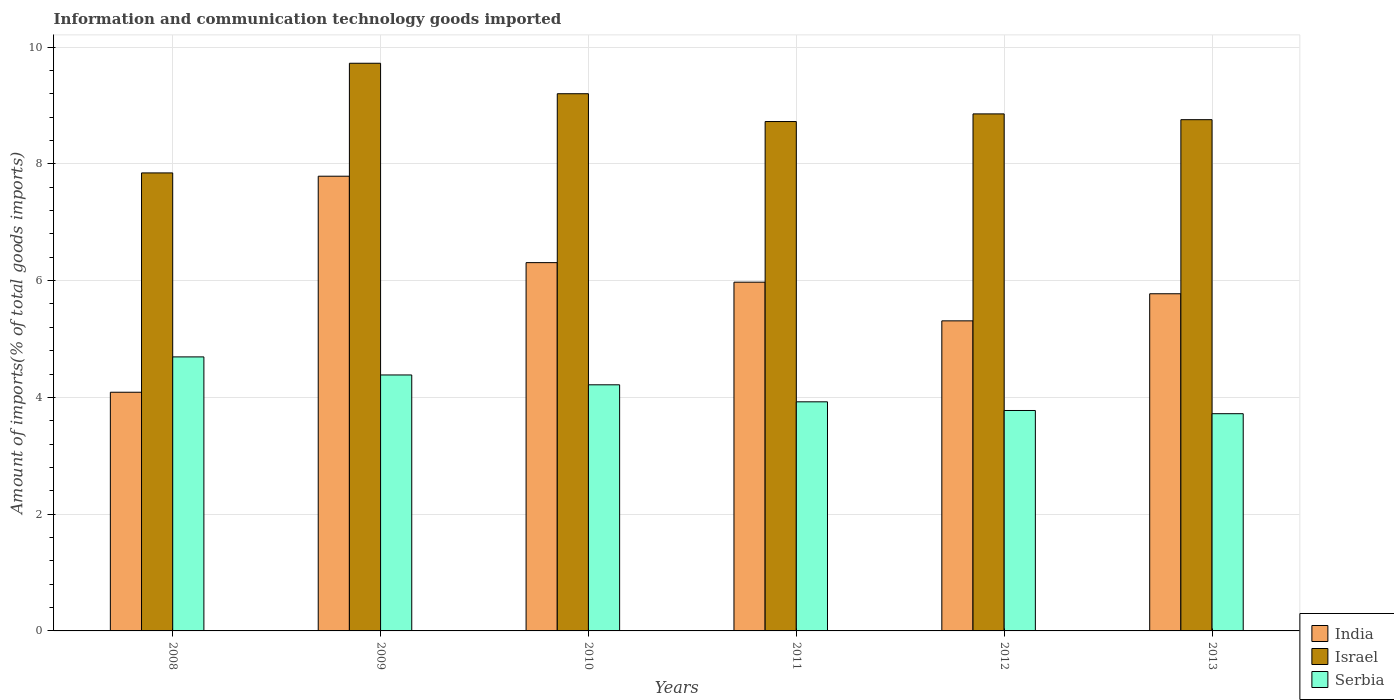How many different coloured bars are there?
Offer a very short reply. 3. How many bars are there on the 5th tick from the right?
Offer a very short reply. 3. What is the amount of goods imported in India in 2012?
Your answer should be compact. 5.31. Across all years, what is the maximum amount of goods imported in Israel?
Ensure brevity in your answer.  9.72. Across all years, what is the minimum amount of goods imported in Serbia?
Keep it short and to the point. 3.72. In which year was the amount of goods imported in Israel maximum?
Ensure brevity in your answer.  2009. In which year was the amount of goods imported in India minimum?
Provide a short and direct response. 2008. What is the total amount of goods imported in India in the graph?
Ensure brevity in your answer.  35.25. What is the difference between the amount of goods imported in India in 2009 and that in 2012?
Provide a short and direct response. 2.48. What is the difference between the amount of goods imported in Serbia in 2011 and the amount of goods imported in India in 2010?
Give a very brief answer. -2.38. What is the average amount of goods imported in Serbia per year?
Provide a short and direct response. 4.12. In the year 2010, what is the difference between the amount of goods imported in Israel and amount of goods imported in Serbia?
Make the answer very short. 4.99. What is the ratio of the amount of goods imported in Serbia in 2011 to that in 2013?
Your answer should be very brief. 1.05. What is the difference between the highest and the second highest amount of goods imported in India?
Your answer should be compact. 1.48. What is the difference between the highest and the lowest amount of goods imported in Israel?
Offer a very short reply. 1.88. In how many years, is the amount of goods imported in India greater than the average amount of goods imported in India taken over all years?
Ensure brevity in your answer.  3. Is the sum of the amount of goods imported in Serbia in 2008 and 2012 greater than the maximum amount of goods imported in Israel across all years?
Keep it short and to the point. No. What does the 3rd bar from the left in 2012 represents?
Offer a terse response. Serbia. What does the 2nd bar from the right in 2012 represents?
Keep it short and to the point. Israel. Is it the case that in every year, the sum of the amount of goods imported in Israel and amount of goods imported in India is greater than the amount of goods imported in Serbia?
Keep it short and to the point. Yes. Are all the bars in the graph horizontal?
Your answer should be compact. No. Does the graph contain any zero values?
Offer a very short reply. No. Does the graph contain grids?
Offer a terse response. Yes. How many legend labels are there?
Your answer should be very brief. 3. What is the title of the graph?
Make the answer very short. Information and communication technology goods imported. Does "Benin" appear as one of the legend labels in the graph?
Your response must be concise. No. What is the label or title of the Y-axis?
Ensure brevity in your answer.  Amount of imports(% of total goods imports). What is the Amount of imports(% of total goods imports) of India in 2008?
Make the answer very short. 4.09. What is the Amount of imports(% of total goods imports) of Israel in 2008?
Your answer should be very brief. 7.85. What is the Amount of imports(% of total goods imports) in Serbia in 2008?
Make the answer very short. 4.69. What is the Amount of imports(% of total goods imports) of India in 2009?
Make the answer very short. 7.79. What is the Amount of imports(% of total goods imports) of Israel in 2009?
Offer a terse response. 9.72. What is the Amount of imports(% of total goods imports) of Serbia in 2009?
Your response must be concise. 4.38. What is the Amount of imports(% of total goods imports) of India in 2010?
Make the answer very short. 6.31. What is the Amount of imports(% of total goods imports) in Israel in 2010?
Offer a terse response. 9.2. What is the Amount of imports(% of total goods imports) of Serbia in 2010?
Offer a very short reply. 4.22. What is the Amount of imports(% of total goods imports) of India in 2011?
Keep it short and to the point. 5.97. What is the Amount of imports(% of total goods imports) of Israel in 2011?
Offer a terse response. 8.73. What is the Amount of imports(% of total goods imports) in Serbia in 2011?
Offer a terse response. 3.92. What is the Amount of imports(% of total goods imports) of India in 2012?
Provide a succinct answer. 5.31. What is the Amount of imports(% of total goods imports) of Israel in 2012?
Provide a short and direct response. 8.86. What is the Amount of imports(% of total goods imports) of Serbia in 2012?
Ensure brevity in your answer.  3.78. What is the Amount of imports(% of total goods imports) in India in 2013?
Your response must be concise. 5.78. What is the Amount of imports(% of total goods imports) in Israel in 2013?
Your response must be concise. 8.76. What is the Amount of imports(% of total goods imports) in Serbia in 2013?
Give a very brief answer. 3.72. Across all years, what is the maximum Amount of imports(% of total goods imports) of India?
Your response must be concise. 7.79. Across all years, what is the maximum Amount of imports(% of total goods imports) of Israel?
Provide a succinct answer. 9.72. Across all years, what is the maximum Amount of imports(% of total goods imports) in Serbia?
Your response must be concise. 4.69. Across all years, what is the minimum Amount of imports(% of total goods imports) in India?
Offer a very short reply. 4.09. Across all years, what is the minimum Amount of imports(% of total goods imports) of Israel?
Your answer should be compact. 7.85. Across all years, what is the minimum Amount of imports(% of total goods imports) in Serbia?
Ensure brevity in your answer.  3.72. What is the total Amount of imports(% of total goods imports) of India in the graph?
Keep it short and to the point. 35.25. What is the total Amount of imports(% of total goods imports) in Israel in the graph?
Offer a terse response. 53.11. What is the total Amount of imports(% of total goods imports) in Serbia in the graph?
Provide a succinct answer. 24.71. What is the difference between the Amount of imports(% of total goods imports) in India in 2008 and that in 2009?
Your response must be concise. -3.7. What is the difference between the Amount of imports(% of total goods imports) of Israel in 2008 and that in 2009?
Your answer should be very brief. -1.88. What is the difference between the Amount of imports(% of total goods imports) in Serbia in 2008 and that in 2009?
Your answer should be compact. 0.31. What is the difference between the Amount of imports(% of total goods imports) of India in 2008 and that in 2010?
Offer a very short reply. -2.22. What is the difference between the Amount of imports(% of total goods imports) of Israel in 2008 and that in 2010?
Offer a very short reply. -1.36. What is the difference between the Amount of imports(% of total goods imports) of Serbia in 2008 and that in 2010?
Your answer should be compact. 0.48. What is the difference between the Amount of imports(% of total goods imports) in India in 2008 and that in 2011?
Ensure brevity in your answer.  -1.89. What is the difference between the Amount of imports(% of total goods imports) of Israel in 2008 and that in 2011?
Keep it short and to the point. -0.88. What is the difference between the Amount of imports(% of total goods imports) of Serbia in 2008 and that in 2011?
Your answer should be very brief. 0.77. What is the difference between the Amount of imports(% of total goods imports) of India in 2008 and that in 2012?
Offer a terse response. -1.22. What is the difference between the Amount of imports(% of total goods imports) in Israel in 2008 and that in 2012?
Your answer should be very brief. -1.01. What is the difference between the Amount of imports(% of total goods imports) in Serbia in 2008 and that in 2012?
Provide a short and direct response. 0.92. What is the difference between the Amount of imports(% of total goods imports) of India in 2008 and that in 2013?
Provide a succinct answer. -1.69. What is the difference between the Amount of imports(% of total goods imports) in Israel in 2008 and that in 2013?
Give a very brief answer. -0.91. What is the difference between the Amount of imports(% of total goods imports) of India in 2009 and that in 2010?
Give a very brief answer. 1.48. What is the difference between the Amount of imports(% of total goods imports) of Israel in 2009 and that in 2010?
Your response must be concise. 0.52. What is the difference between the Amount of imports(% of total goods imports) of Serbia in 2009 and that in 2010?
Keep it short and to the point. 0.17. What is the difference between the Amount of imports(% of total goods imports) in India in 2009 and that in 2011?
Offer a very short reply. 1.81. What is the difference between the Amount of imports(% of total goods imports) of Israel in 2009 and that in 2011?
Ensure brevity in your answer.  1. What is the difference between the Amount of imports(% of total goods imports) of Serbia in 2009 and that in 2011?
Give a very brief answer. 0.46. What is the difference between the Amount of imports(% of total goods imports) in India in 2009 and that in 2012?
Ensure brevity in your answer.  2.48. What is the difference between the Amount of imports(% of total goods imports) in Israel in 2009 and that in 2012?
Your answer should be very brief. 0.87. What is the difference between the Amount of imports(% of total goods imports) of Serbia in 2009 and that in 2012?
Keep it short and to the point. 0.61. What is the difference between the Amount of imports(% of total goods imports) of India in 2009 and that in 2013?
Keep it short and to the point. 2.01. What is the difference between the Amount of imports(% of total goods imports) in Israel in 2009 and that in 2013?
Provide a succinct answer. 0.97. What is the difference between the Amount of imports(% of total goods imports) of Serbia in 2009 and that in 2013?
Keep it short and to the point. 0.66. What is the difference between the Amount of imports(% of total goods imports) of India in 2010 and that in 2011?
Give a very brief answer. 0.33. What is the difference between the Amount of imports(% of total goods imports) of Israel in 2010 and that in 2011?
Make the answer very short. 0.48. What is the difference between the Amount of imports(% of total goods imports) of Serbia in 2010 and that in 2011?
Your answer should be very brief. 0.29. What is the difference between the Amount of imports(% of total goods imports) of Israel in 2010 and that in 2012?
Give a very brief answer. 0.35. What is the difference between the Amount of imports(% of total goods imports) in Serbia in 2010 and that in 2012?
Make the answer very short. 0.44. What is the difference between the Amount of imports(% of total goods imports) of India in 2010 and that in 2013?
Provide a short and direct response. 0.53. What is the difference between the Amount of imports(% of total goods imports) in Israel in 2010 and that in 2013?
Provide a succinct answer. 0.44. What is the difference between the Amount of imports(% of total goods imports) of Serbia in 2010 and that in 2013?
Offer a terse response. 0.49. What is the difference between the Amount of imports(% of total goods imports) in India in 2011 and that in 2012?
Make the answer very short. 0.66. What is the difference between the Amount of imports(% of total goods imports) in Israel in 2011 and that in 2012?
Provide a short and direct response. -0.13. What is the difference between the Amount of imports(% of total goods imports) in Serbia in 2011 and that in 2012?
Provide a short and direct response. 0.15. What is the difference between the Amount of imports(% of total goods imports) in India in 2011 and that in 2013?
Give a very brief answer. 0.2. What is the difference between the Amount of imports(% of total goods imports) of Israel in 2011 and that in 2013?
Give a very brief answer. -0.03. What is the difference between the Amount of imports(% of total goods imports) in Serbia in 2011 and that in 2013?
Your answer should be very brief. 0.2. What is the difference between the Amount of imports(% of total goods imports) of India in 2012 and that in 2013?
Your response must be concise. -0.46. What is the difference between the Amount of imports(% of total goods imports) in Israel in 2012 and that in 2013?
Your answer should be very brief. 0.1. What is the difference between the Amount of imports(% of total goods imports) of Serbia in 2012 and that in 2013?
Ensure brevity in your answer.  0.06. What is the difference between the Amount of imports(% of total goods imports) in India in 2008 and the Amount of imports(% of total goods imports) in Israel in 2009?
Provide a short and direct response. -5.64. What is the difference between the Amount of imports(% of total goods imports) of India in 2008 and the Amount of imports(% of total goods imports) of Serbia in 2009?
Your answer should be compact. -0.3. What is the difference between the Amount of imports(% of total goods imports) of Israel in 2008 and the Amount of imports(% of total goods imports) of Serbia in 2009?
Provide a succinct answer. 3.46. What is the difference between the Amount of imports(% of total goods imports) in India in 2008 and the Amount of imports(% of total goods imports) in Israel in 2010?
Your answer should be very brief. -5.11. What is the difference between the Amount of imports(% of total goods imports) in India in 2008 and the Amount of imports(% of total goods imports) in Serbia in 2010?
Ensure brevity in your answer.  -0.13. What is the difference between the Amount of imports(% of total goods imports) of Israel in 2008 and the Amount of imports(% of total goods imports) of Serbia in 2010?
Provide a short and direct response. 3.63. What is the difference between the Amount of imports(% of total goods imports) in India in 2008 and the Amount of imports(% of total goods imports) in Israel in 2011?
Make the answer very short. -4.64. What is the difference between the Amount of imports(% of total goods imports) in India in 2008 and the Amount of imports(% of total goods imports) in Serbia in 2011?
Offer a terse response. 0.16. What is the difference between the Amount of imports(% of total goods imports) of Israel in 2008 and the Amount of imports(% of total goods imports) of Serbia in 2011?
Give a very brief answer. 3.92. What is the difference between the Amount of imports(% of total goods imports) of India in 2008 and the Amount of imports(% of total goods imports) of Israel in 2012?
Keep it short and to the point. -4.77. What is the difference between the Amount of imports(% of total goods imports) in India in 2008 and the Amount of imports(% of total goods imports) in Serbia in 2012?
Give a very brief answer. 0.31. What is the difference between the Amount of imports(% of total goods imports) of Israel in 2008 and the Amount of imports(% of total goods imports) of Serbia in 2012?
Ensure brevity in your answer.  4.07. What is the difference between the Amount of imports(% of total goods imports) of India in 2008 and the Amount of imports(% of total goods imports) of Israel in 2013?
Keep it short and to the point. -4.67. What is the difference between the Amount of imports(% of total goods imports) of India in 2008 and the Amount of imports(% of total goods imports) of Serbia in 2013?
Give a very brief answer. 0.37. What is the difference between the Amount of imports(% of total goods imports) in Israel in 2008 and the Amount of imports(% of total goods imports) in Serbia in 2013?
Your answer should be compact. 4.12. What is the difference between the Amount of imports(% of total goods imports) in India in 2009 and the Amount of imports(% of total goods imports) in Israel in 2010?
Ensure brevity in your answer.  -1.41. What is the difference between the Amount of imports(% of total goods imports) in India in 2009 and the Amount of imports(% of total goods imports) in Serbia in 2010?
Keep it short and to the point. 3.57. What is the difference between the Amount of imports(% of total goods imports) in Israel in 2009 and the Amount of imports(% of total goods imports) in Serbia in 2010?
Ensure brevity in your answer.  5.51. What is the difference between the Amount of imports(% of total goods imports) in India in 2009 and the Amount of imports(% of total goods imports) in Israel in 2011?
Offer a terse response. -0.94. What is the difference between the Amount of imports(% of total goods imports) of India in 2009 and the Amount of imports(% of total goods imports) of Serbia in 2011?
Offer a terse response. 3.86. What is the difference between the Amount of imports(% of total goods imports) of Israel in 2009 and the Amount of imports(% of total goods imports) of Serbia in 2011?
Keep it short and to the point. 5.8. What is the difference between the Amount of imports(% of total goods imports) in India in 2009 and the Amount of imports(% of total goods imports) in Israel in 2012?
Ensure brevity in your answer.  -1.07. What is the difference between the Amount of imports(% of total goods imports) of India in 2009 and the Amount of imports(% of total goods imports) of Serbia in 2012?
Provide a short and direct response. 4.01. What is the difference between the Amount of imports(% of total goods imports) of Israel in 2009 and the Amount of imports(% of total goods imports) of Serbia in 2012?
Offer a terse response. 5.95. What is the difference between the Amount of imports(% of total goods imports) in India in 2009 and the Amount of imports(% of total goods imports) in Israel in 2013?
Give a very brief answer. -0.97. What is the difference between the Amount of imports(% of total goods imports) of India in 2009 and the Amount of imports(% of total goods imports) of Serbia in 2013?
Give a very brief answer. 4.07. What is the difference between the Amount of imports(% of total goods imports) of Israel in 2009 and the Amount of imports(% of total goods imports) of Serbia in 2013?
Give a very brief answer. 6. What is the difference between the Amount of imports(% of total goods imports) in India in 2010 and the Amount of imports(% of total goods imports) in Israel in 2011?
Offer a very short reply. -2.42. What is the difference between the Amount of imports(% of total goods imports) of India in 2010 and the Amount of imports(% of total goods imports) of Serbia in 2011?
Your answer should be compact. 2.38. What is the difference between the Amount of imports(% of total goods imports) in Israel in 2010 and the Amount of imports(% of total goods imports) in Serbia in 2011?
Keep it short and to the point. 5.28. What is the difference between the Amount of imports(% of total goods imports) in India in 2010 and the Amount of imports(% of total goods imports) in Israel in 2012?
Offer a terse response. -2.55. What is the difference between the Amount of imports(% of total goods imports) in India in 2010 and the Amount of imports(% of total goods imports) in Serbia in 2012?
Your answer should be very brief. 2.53. What is the difference between the Amount of imports(% of total goods imports) of Israel in 2010 and the Amount of imports(% of total goods imports) of Serbia in 2012?
Make the answer very short. 5.43. What is the difference between the Amount of imports(% of total goods imports) of India in 2010 and the Amount of imports(% of total goods imports) of Israel in 2013?
Ensure brevity in your answer.  -2.45. What is the difference between the Amount of imports(% of total goods imports) of India in 2010 and the Amount of imports(% of total goods imports) of Serbia in 2013?
Offer a very short reply. 2.59. What is the difference between the Amount of imports(% of total goods imports) of Israel in 2010 and the Amount of imports(% of total goods imports) of Serbia in 2013?
Offer a very short reply. 5.48. What is the difference between the Amount of imports(% of total goods imports) of India in 2011 and the Amount of imports(% of total goods imports) of Israel in 2012?
Give a very brief answer. -2.88. What is the difference between the Amount of imports(% of total goods imports) in India in 2011 and the Amount of imports(% of total goods imports) in Serbia in 2012?
Ensure brevity in your answer.  2.2. What is the difference between the Amount of imports(% of total goods imports) in Israel in 2011 and the Amount of imports(% of total goods imports) in Serbia in 2012?
Provide a short and direct response. 4.95. What is the difference between the Amount of imports(% of total goods imports) in India in 2011 and the Amount of imports(% of total goods imports) in Israel in 2013?
Provide a short and direct response. -2.78. What is the difference between the Amount of imports(% of total goods imports) in India in 2011 and the Amount of imports(% of total goods imports) in Serbia in 2013?
Your answer should be compact. 2.25. What is the difference between the Amount of imports(% of total goods imports) in Israel in 2011 and the Amount of imports(% of total goods imports) in Serbia in 2013?
Provide a short and direct response. 5. What is the difference between the Amount of imports(% of total goods imports) in India in 2012 and the Amount of imports(% of total goods imports) in Israel in 2013?
Provide a succinct answer. -3.45. What is the difference between the Amount of imports(% of total goods imports) of India in 2012 and the Amount of imports(% of total goods imports) of Serbia in 2013?
Make the answer very short. 1.59. What is the difference between the Amount of imports(% of total goods imports) of Israel in 2012 and the Amount of imports(% of total goods imports) of Serbia in 2013?
Offer a very short reply. 5.14. What is the average Amount of imports(% of total goods imports) of India per year?
Your answer should be very brief. 5.87. What is the average Amount of imports(% of total goods imports) of Israel per year?
Keep it short and to the point. 8.85. What is the average Amount of imports(% of total goods imports) in Serbia per year?
Provide a short and direct response. 4.12. In the year 2008, what is the difference between the Amount of imports(% of total goods imports) in India and Amount of imports(% of total goods imports) in Israel?
Your answer should be compact. -3.76. In the year 2008, what is the difference between the Amount of imports(% of total goods imports) of India and Amount of imports(% of total goods imports) of Serbia?
Offer a terse response. -0.61. In the year 2008, what is the difference between the Amount of imports(% of total goods imports) in Israel and Amount of imports(% of total goods imports) in Serbia?
Ensure brevity in your answer.  3.15. In the year 2009, what is the difference between the Amount of imports(% of total goods imports) of India and Amount of imports(% of total goods imports) of Israel?
Keep it short and to the point. -1.93. In the year 2009, what is the difference between the Amount of imports(% of total goods imports) of India and Amount of imports(% of total goods imports) of Serbia?
Offer a terse response. 3.4. In the year 2009, what is the difference between the Amount of imports(% of total goods imports) of Israel and Amount of imports(% of total goods imports) of Serbia?
Provide a short and direct response. 5.34. In the year 2010, what is the difference between the Amount of imports(% of total goods imports) in India and Amount of imports(% of total goods imports) in Israel?
Offer a terse response. -2.89. In the year 2010, what is the difference between the Amount of imports(% of total goods imports) in India and Amount of imports(% of total goods imports) in Serbia?
Make the answer very short. 2.09. In the year 2010, what is the difference between the Amount of imports(% of total goods imports) in Israel and Amount of imports(% of total goods imports) in Serbia?
Keep it short and to the point. 4.99. In the year 2011, what is the difference between the Amount of imports(% of total goods imports) in India and Amount of imports(% of total goods imports) in Israel?
Provide a succinct answer. -2.75. In the year 2011, what is the difference between the Amount of imports(% of total goods imports) of India and Amount of imports(% of total goods imports) of Serbia?
Your answer should be compact. 2.05. In the year 2011, what is the difference between the Amount of imports(% of total goods imports) in Israel and Amount of imports(% of total goods imports) in Serbia?
Provide a short and direct response. 4.8. In the year 2012, what is the difference between the Amount of imports(% of total goods imports) in India and Amount of imports(% of total goods imports) in Israel?
Your answer should be very brief. -3.54. In the year 2012, what is the difference between the Amount of imports(% of total goods imports) of India and Amount of imports(% of total goods imports) of Serbia?
Offer a very short reply. 1.54. In the year 2012, what is the difference between the Amount of imports(% of total goods imports) in Israel and Amount of imports(% of total goods imports) in Serbia?
Provide a succinct answer. 5.08. In the year 2013, what is the difference between the Amount of imports(% of total goods imports) in India and Amount of imports(% of total goods imports) in Israel?
Offer a very short reply. -2.98. In the year 2013, what is the difference between the Amount of imports(% of total goods imports) of India and Amount of imports(% of total goods imports) of Serbia?
Provide a succinct answer. 2.05. In the year 2013, what is the difference between the Amount of imports(% of total goods imports) in Israel and Amount of imports(% of total goods imports) in Serbia?
Your answer should be compact. 5.04. What is the ratio of the Amount of imports(% of total goods imports) of India in 2008 to that in 2009?
Keep it short and to the point. 0.52. What is the ratio of the Amount of imports(% of total goods imports) in Israel in 2008 to that in 2009?
Give a very brief answer. 0.81. What is the ratio of the Amount of imports(% of total goods imports) of Serbia in 2008 to that in 2009?
Offer a terse response. 1.07. What is the ratio of the Amount of imports(% of total goods imports) in India in 2008 to that in 2010?
Make the answer very short. 0.65. What is the ratio of the Amount of imports(% of total goods imports) in Israel in 2008 to that in 2010?
Keep it short and to the point. 0.85. What is the ratio of the Amount of imports(% of total goods imports) in Serbia in 2008 to that in 2010?
Keep it short and to the point. 1.11. What is the ratio of the Amount of imports(% of total goods imports) of India in 2008 to that in 2011?
Your response must be concise. 0.68. What is the ratio of the Amount of imports(% of total goods imports) in Israel in 2008 to that in 2011?
Provide a succinct answer. 0.9. What is the ratio of the Amount of imports(% of total goods imports) in Serbia in 2008 to that in 2011?
Your response must be concise. 1.2. What is the ratio of the Amount of imports(% of total goods imports) of India in 2008 to that in 2012?
Your response must be concise. 0.77. What is the ratio of the Amount of imports(% of total goods imports) in Israel in 2008 to that in 2012?
Provide a succinct answer. 0.89. What is the ratio of the Amount of imports(% of total goods imports) in Serbia in 2008 to that in 2012?
Make the answer very short. 1.24. What is the ratio of the Amount of imports(% of total goods imports) in India in 2008 to that in 2013?
Your response must be concise. 0.71. What is the ratio of the Amount of imports(% of total goods imports) of Israel in 2008 to that in 2013?
Your answer should be very brief. 0.9. What is the ratio of the Amount of imports(% of total goods imports) in Serbia in 2008 to that in 2013?
Offer a very short reply. 1.26. What is the ratio of the Amount of imports(% of total goods imports) of India in 2009 to that in 2010?
Offer a very short reply. 1.23. What is the ratio of the Amount of imports(% of total goods imports) of Israel in 2009 to that in 2010?
Give a very brief answer. 1.06. What is the ratio of the Amount of imports(% of total goods imports) in India in 2009 to that in 2011?
Provide a short and direct response. 1.3. What is the ratio of the Amount of imports(% of total goods imports) of Israel in 2009 to that in 2011?
Offer a terse response. 1.11. What is the ratio of the Amount of imports(% of total goods imports) of Serbia in 2009 to that in 2011?
Your answer should be very brief. 1.12. What is the ratio of the Amount of imports(% of total goods imports) of India in 2009 to that in 2012?
Provide a short and direct response. 1.47. What is the ratio of the Amount of imports(% of total goods imports) in Israel in 2009 to that in 2012?
Your answer should be very brief. 1.1. What is the ratio of the Amount of imports(% of total goods imports) in Serbia in 2009 to that in 2012?
Your response must be concise. 1.16. What is the ratio of the Amount of imports(% of total goods imports) of India in 2009 to that in 2013?
Offer a very short reply. 1.35. What is the ratio of the Amount of imports(% of total goods imports) of Israel in 2009 to that in 2013?
Provide a succinct answer. 1.11. What is the ratio of the Amount of imports(% of total goods imports) of Serbia in 2009 to that in 2013?
Provide a short and direct response. 1.18. What is the ratio of the Amount of imports(% of total goods imports) in India in 2010 to that in 2011?
Keep it short and to the point. 1.06. What is the ratio of the Amount of imports(% of total goods imports) of Israel in 2010 to that in 2011?
Your answer should be very brief. 1.05. What is the ratio of the Amount of imports(% of total goods imports) of Serbia in 2010 to that in 2011?
Provide a succinct answer. 1.07. What is the ratio of the Amount of imports(% of total goods imports) of India in 2010 to that in 2012?
Ensure brevity in your answer.  1.19. What is the ratio of the Amount of imports(% of total goods imports) of Israel in 2010 to that in 2012?
Keep it short and to the point. 1.04. What is the ratio of the Amount of imports(% of total goods imports) in Serbia in 2010 to that in 2012?
Your answer should be compact. 1.12. What is the ratio of the Amount of imports(% of total goods imports) in India in 2010 to that in 2013?
Your response must be concise. 1.09. What is the ratio of the Amount of imports(% of total goods imports) in Israel in 2010 to that in 2013?
Provide a succinct answer. 1.05. What is the ratio of the Amount of imports(% of total goods imports) in Serbia in 2010 to that in 2013?
Give a very brief answer. 1.13. What is the ratio of the Amount of imports(% of total goods imports) of India in 2011 to that in 2012?
Provide a short and direct response. 1.12. What is the ratio of the Amount of imports(% of total goods imports) of Israel in 2011 to that in 2012?
Provide a succinct answer. 0.99. What is the ratio of the Amount of imports(% of total goods imports) of Serbia in 2011 to that in 2012?
Offer a very short reply. 1.04. What is the ratio of the Amount of imports(% of total goods imports) in India in 2011 to that in 2013?
Your response must be concise. 1.03. What is the ratio of the Amount of imports(% of total goods imports) of Serbia in 2011 to that in 2013?
Provide a succinct answer. 1.05. What is the ratio of the Amount of imports(% of total goods imports) of India in 2012 to that in 2013?
Provide a succinct answer. 0.92. What is the ratio of the Amount of imports(% of total goods imports) in Israel in 2012 to that in 2013?
Offer a very short reply. 1.01. What is the ratio of the Amount of imports(% of total goods imports) of Serbia in 2012 to that in 2013?
Offer a terse response. 1.01. What is the difference between the highest and the second highest Amount of imports(% of total goods imports) of India?
Ensure brevity in your answer.  1.48. What is the difference between the highest and the second highest Amount of imports(% of total goods imports) in Israel?
Provide a short and direct response. 0.52. What is the difference between the highest and the second highest Amount of imports(% of total goods imports) in Serbia?
Ensure brevity in your answer.  0.31. What is the difference between the highest and the lowest Amount of imports(% of total goods imports) in India?
Provide a short and direct response. 3.7. What is the difference between the highest and the lowest Amount of imports(% of total goods imports) of Israel?
Provide a short and direct response. 1.88. What is the difference between the highest and the lowest Amount of imports(% of total goods imports) in Serbia?
Offer a very short reply. 0.97. 